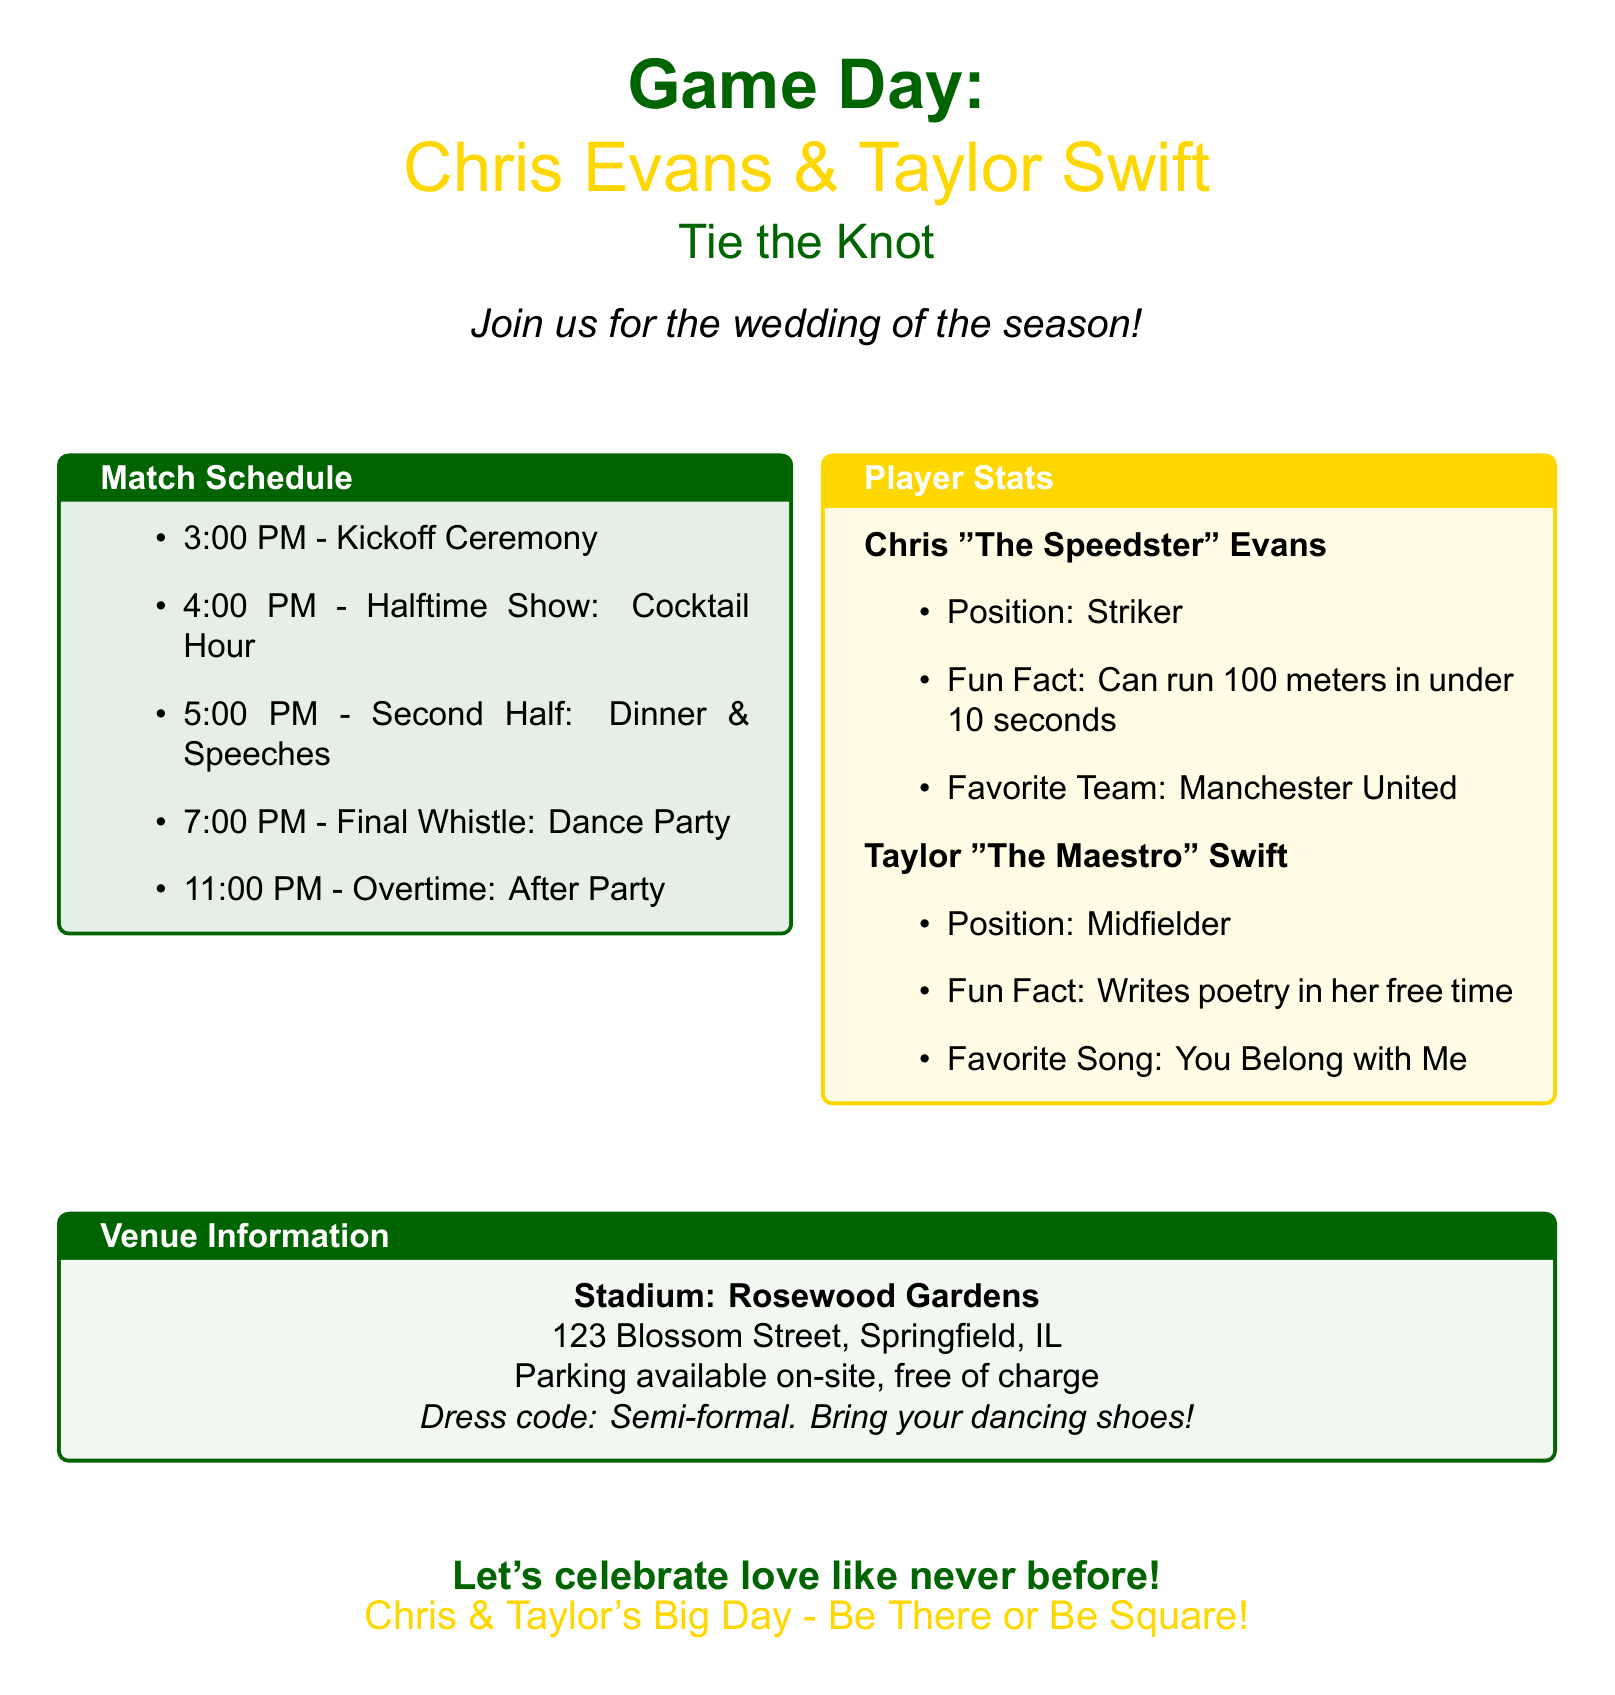What time does the ceremony start? The ceremony starts at 3:00 PM, as listed in the match schedule.
Answer: 3:00 PM What is Chris Evans’ favorite team? This information is found in the player stats section under Chris Evans’ profile.
Answer: Manchester United What is the venue for the wedding? The venue is stated in the venue information section at the bottom of the document.
Answer: Rosewood Gardens What activity occurs at 7:00 PM? The event scheduled at 7:00 PM is mentioned in the match schedule section.
Answer: Dance Party Who is known as "The Maestro"? This name is linked to one of the individuals in the player stats section, where their nickname is listed.
Answer: Taylor Swift How long is the cocktail hour? The cocktail hour is part of the halftime show and is indicated as starting at 4:00 PM, lasting until 5:00 PM.
Answer: 1 hour What is the dress code? The dress code can be found in the venue information section of the document.
Answer: Semi-formal What unique skill does Chris Evans have? This skill is detailed in the player stats section under Chris Evans’ profile.
Answer: Can run 100 meters in under 10 seconds 